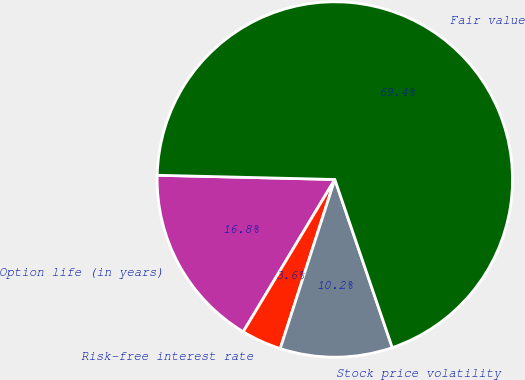Convert chart. <chart><loc_0><loc_0><loc_500><loc_500><pie_chart><fcel>Option life (in years)<fcel>Risk-free interest rate<fcel>Stock price volatility<fcel>Fair value<nl><fcel>16.76%<fcel>3.65%<fcel>10.21%<fcel>69.38%<nl></chart> 